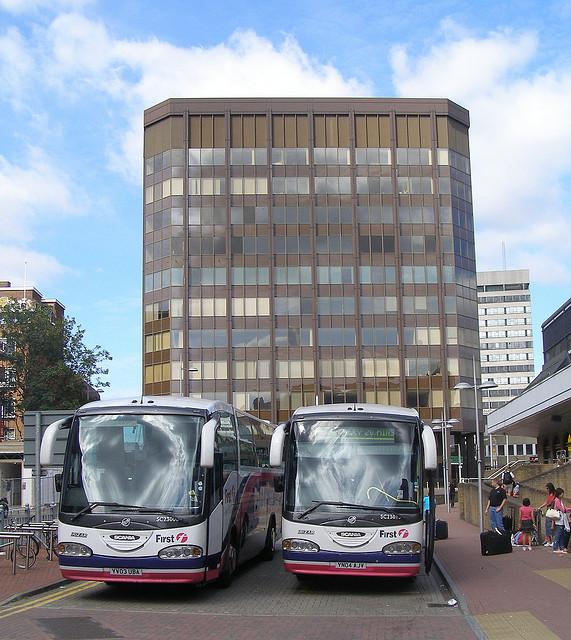What is the black bag on the sidewalk? Please explain your reasoning. luggage. The people are waiting to board the bus because they are travelling and have their suitcase full of belongings with them. 